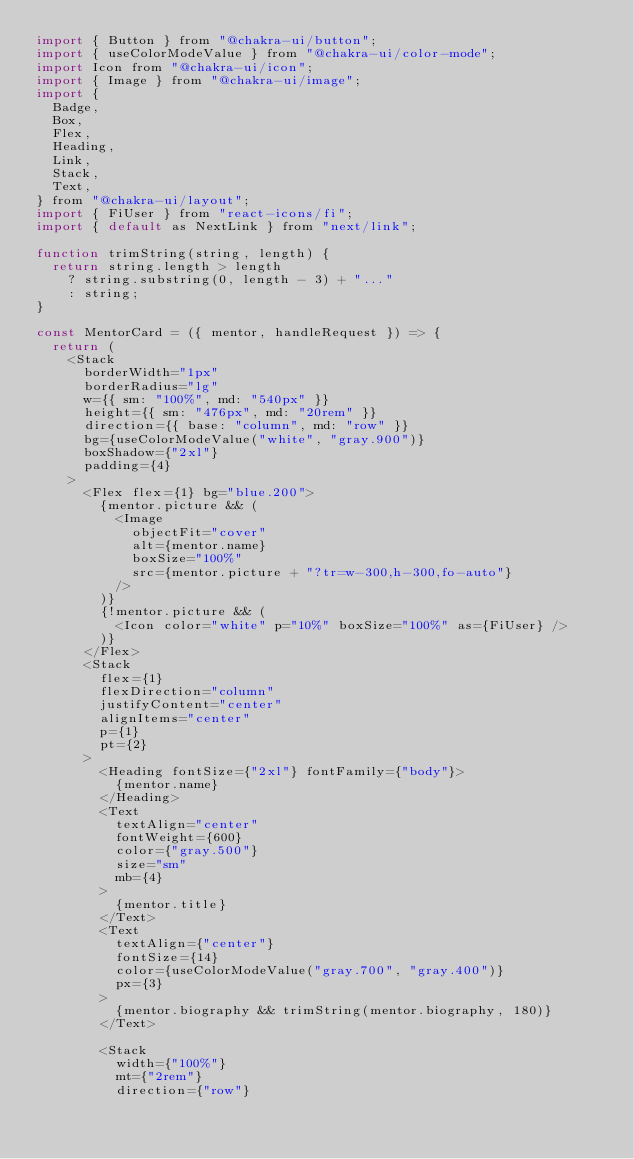<code> <loc_0><loc_0><loc_500><loc_500><_JavaScript_>import { Button } from "@chakra-ui/button";
import { useColorModeValue } from "@chakra-ui/color-mode";
import Icon from "@chakra-ui/icon";
import { Image } from "@chakra-ui/image";
import {
  Badge,
  Box,
  Flex,
  Heading,
  Link,
  Stack,
  Text,
} from "@chakra-ui/layout";
import { FiUser } from "react-icons/fi";
import { default as NextLink } from "next/link";

function trimString(string, length) {
  return string.length > length
    ? string.substring(0, length - 3) + "..."
    : string;
}

const MentorCard = ({ mentor, handleRequest }) => {
  return (
    <Stack
      borderWidth="1px"
      borderRadius="lg"
      w={{ sm: "100%", md: "540px" }}
      height={{ sm: "476px", md: "20rem" }}
      direction={{ base: "column", md: "row" }}
      bg={useColorModeValue("white", "gray.900")}
      boxShadow={"2xl"}
      padding={4}
    >
      <Flex flex={1} bg="blue.200">
        {mentor.picture && (
          <Image
            objectFit="cover"
            alt={mentor.name}
            boxSize="100%"
            src={mentor.picture + "?tr=w-300,h-300,fo-auto"}
          />
        )}
        {!mentor.picture && (
          <Icon color="white" p="10%" boxSize="100%" as={FiUser} />
        )}
      </Flex>
      <Stack
        flex={1}
        flexDirection="column"
        justifyContent="center"
        alignItems="center"
        p={1}
        pt={2}
      >
        <Heading fontSize={"2xl"} fontFamily={"body"}>
          {mentor.name}
        </Heading>
        <Text
          textAlign="center"
          fontWeight={600}
          color={"gray.500"}
          size="sm"
          mb={4}
        >
          {mentor.title}
        </Text>
        <Text
          textAlign={"center"}
          fontSize={14}
          color={useColorModeValue("gray.700", "gray.400")}
          px={3}
        >
          {mentor.biography && trimString(mentor.biography, 180)}
        </Text>

        <Stack
          width={"100%"}
          mt={"2rem"}
          direction={"row"}</code> 